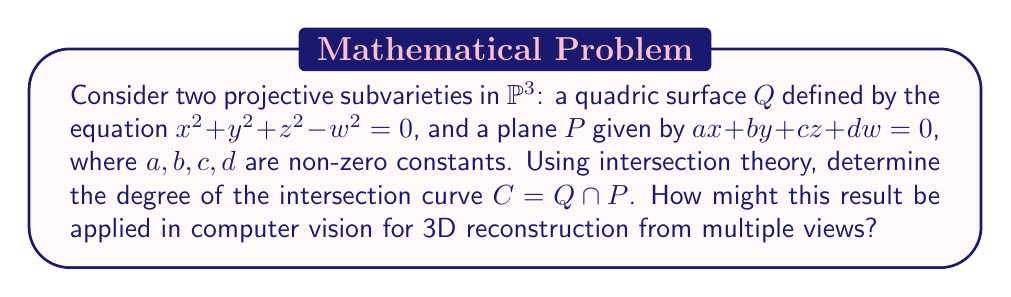Show me your answer to this math problem. Let's approach this step-by-step:

1) In projective space $\mathbb{P}^3$, the degree of an intersection is given by Bézout's theorem. This states that the degree of the intersection of two projective varieties is the product of their degrees.

2) The quadric surface $Q$ is defined by a homogeneous polynomial of degree 2, so $\deg(Q) = 2$.

3) The plane $P$ is defined by a homogeneous linear equation, so $\deg(P) = 1$.

4) By Bézout's theorem, the degree of the intersection curve $C = Q \cap P$ is:

   $$\deg(C) = \deg(Q) \cdot \deg(P) = 2 \cdot 1 = 2$$

5) This means that $C$ is a conic curve (e.g., ellipse, parabola, or hyperbola) in the plane $P$.

Application to Computer Vision:

6) In 3D reconstruction from multiple views, we often need to determine the intersection of geometric objects in projective space.

7) For example, in the case of two-view geometry, the epipolar constraint defines a quadric surface in $\mathbb{P}^3$ (similar to $Q$).

8) When we consider a third view, it introduces a plane in $\mathbb{P}^3$ (similar to $P$).

9) The intersection of this quadric and plane gives us a conic curve, which represents the possible 3D positions of a point seen in all three views.

10) Understanding that this intersection is always a conic (degree 2) allows us to develop efficient algorithms for triangulation and 3D point reconstruction in multi-view geometry.
Answer: Degree of intersection: 2. Application: Efficient 3D point reconstruction in multi-view geometry. 